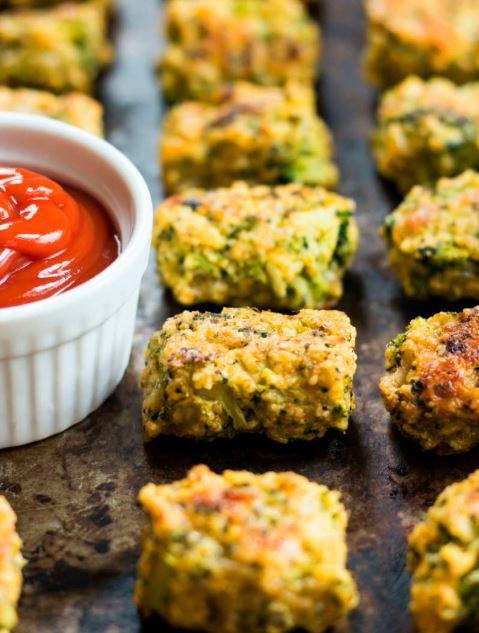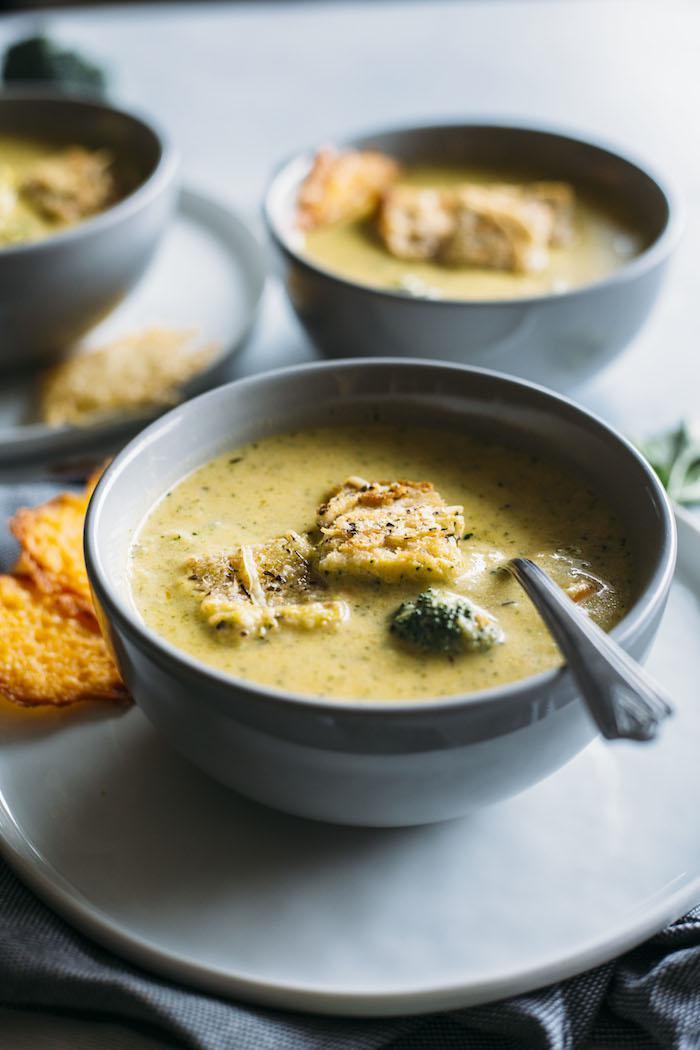The first image is the image on the left, the second image is the image on the right. Examine the images to the left and right. Is the description "An image shows a utensil inserted in a bowl of creamy soup." accurate? Answer yes or no. Yes. The first image is the image on the left, the second image is the image on the right. For the images displayed, is the sentence "A bowl of creamy soup in a white bowl with spoon is garnished with pieces of broccoli and grated cheese." factually correct? Answer yes or no. No. 